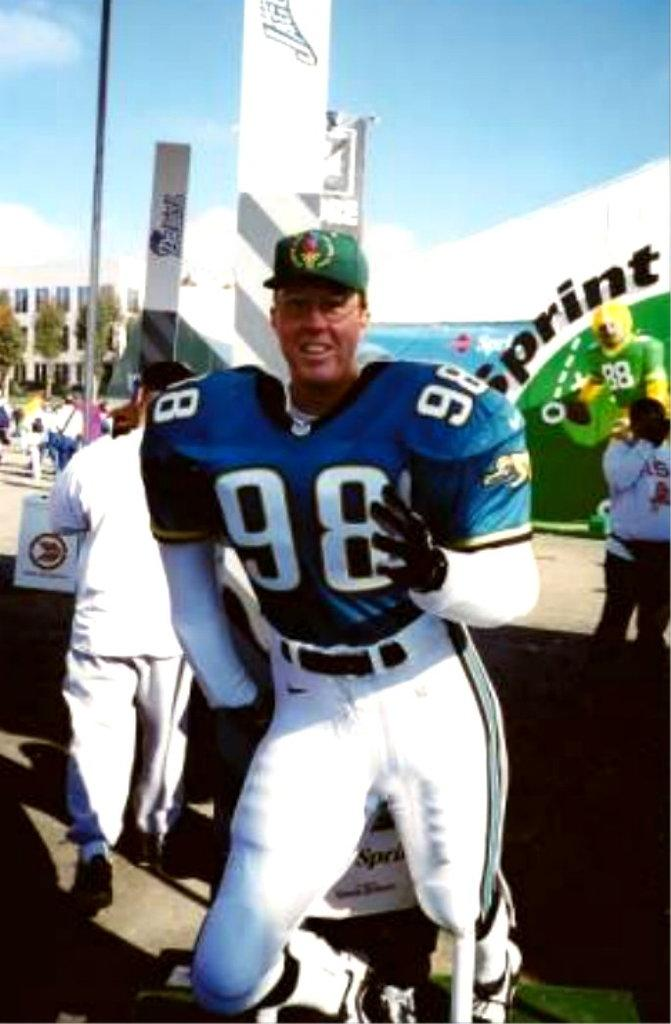<image>
Present a compact description of the photo's key features. A man in a football uniform with 98 on the front of his jersey. 